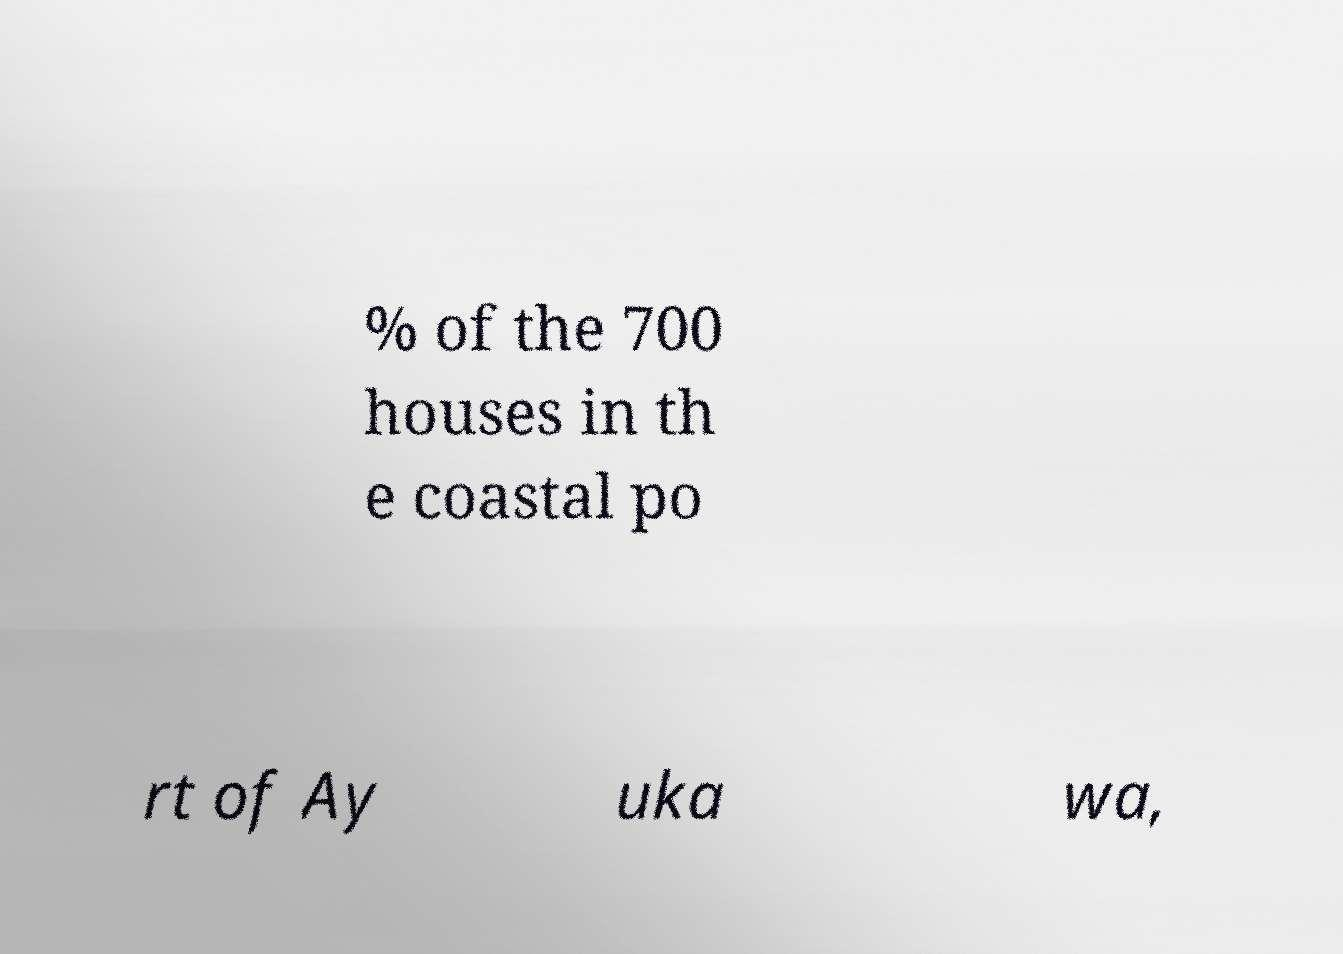Could you assist in decoding the text presented in this image and type it out clearly? % of the 700 houses in th e coastal po rt of Ay uka wa, 